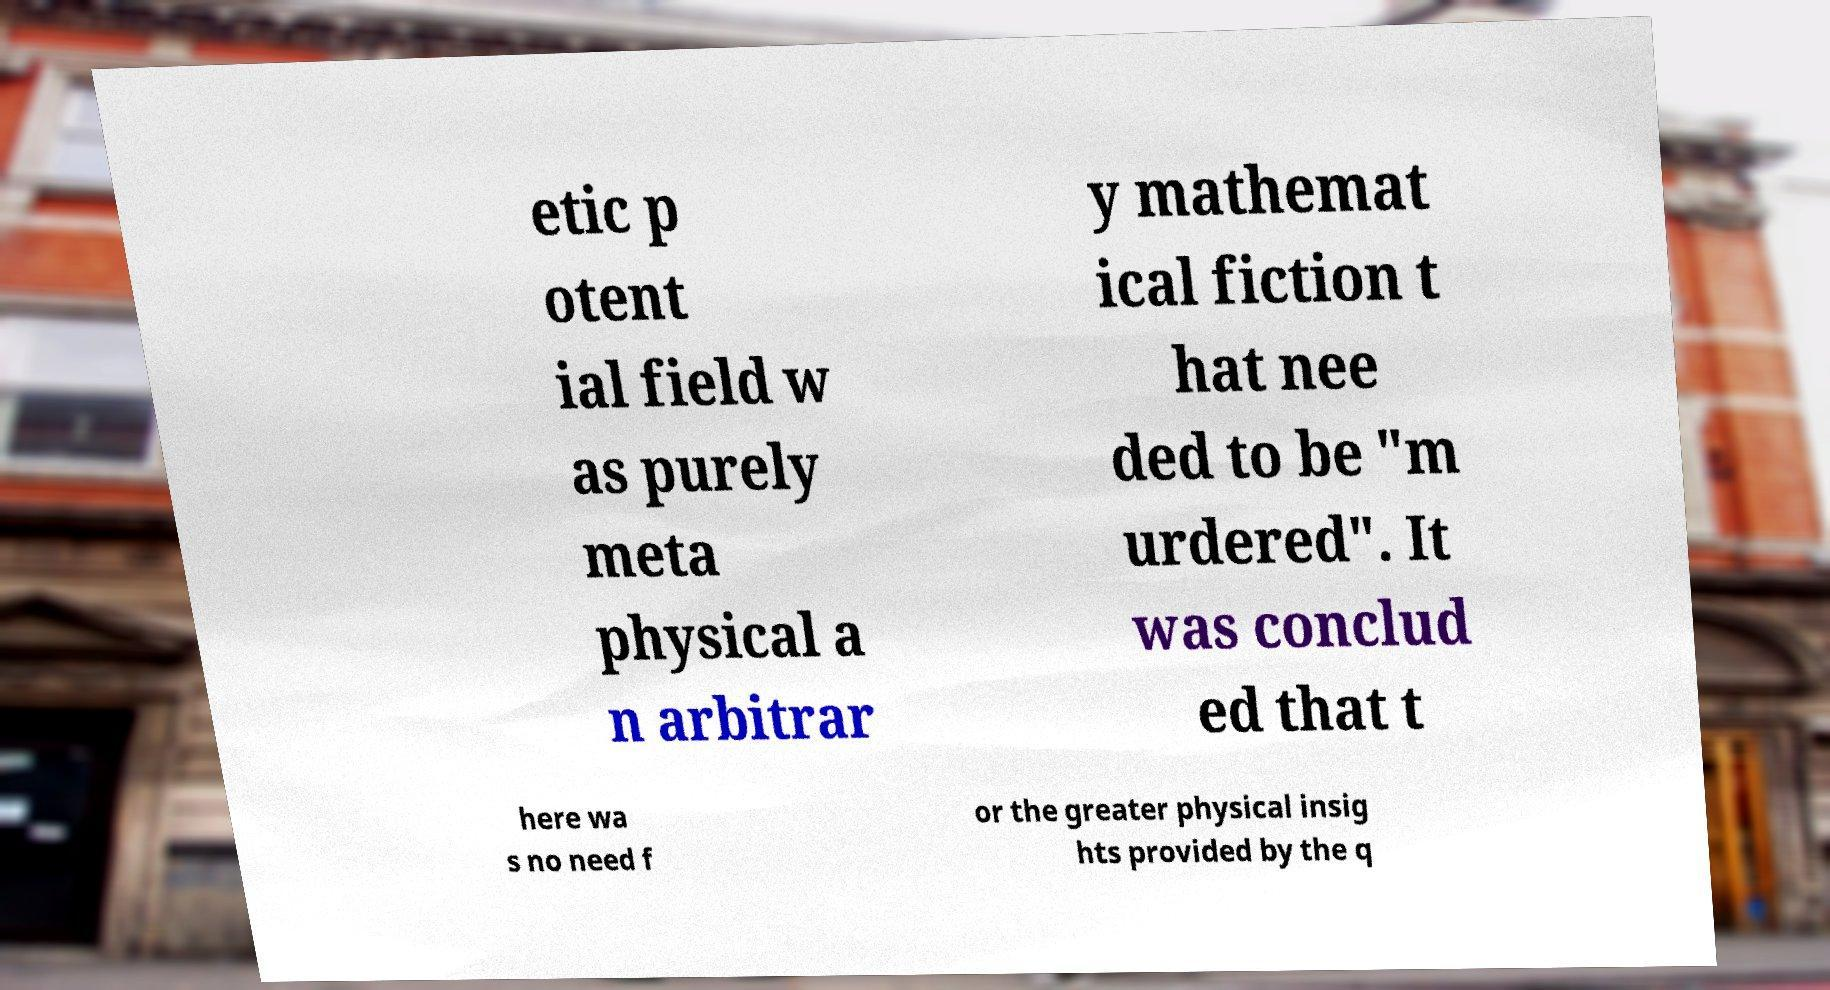I need the written content from this picture converted into text. Can you do that? etic p otent ial field w as purely meta physical a n arbitrar y mathemat ical fiction t hat nee ded to be "m urdered". It was conclud ed that t here wa s no need f or the greater physical insig hts provided by the q 